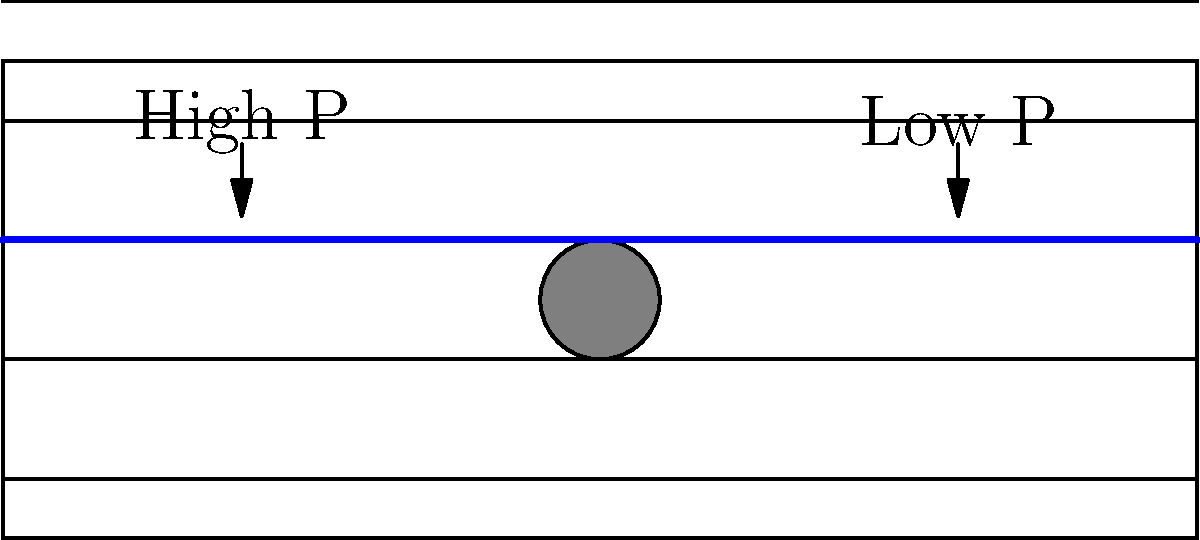In a wind tunnel experiment, a circular object is placed in the airflow as shown in the diagram. Considering the ethical implications of data interpretation in research, how would you describe the relationship between the flow pattern and pressure distribution around the object? To answer this question ethically and accurately, we need to consider the following steps:

1. Observe the flow lines:
   The flow lines bend around the circular object, indicating a change in velocity.

2. Analyze velocity changes:
   As the flow lines compress above and below the object, the air velocity increases in these regions.

3. Apply Bernoulli's principle:
   Bernoulli's principle states that an increase in fluid velocity corresponds to a decrease in pressure.

4. Identify pressure zones:
   - Higher pressure zone: In front of the object where flow lines diverge and velocity decreases.
   - Lower pressure zone: Above and below the object where flow lines converge and velocity increases.

5. Consider ethical implications:
   As a clinical psychologist concerned with ethical practices, it's important to:
   - Accurately report and interpret the data without bias.
   - Consider potential impacts of misinterpreting or misrepresenting the results.
   - Ensure transparency in the methodology and analysis.

6. Formulate the relationship:
   The flow pattern directly influences the pressure distribution. Areas of high velocity correspond to low pressure, and areas of low velocity correspond to high pressure.
Answer: The flow pattern creates high pressure in front of the object and low pressure above and below, due to velocity changes, as per Bernoulli's principle. 